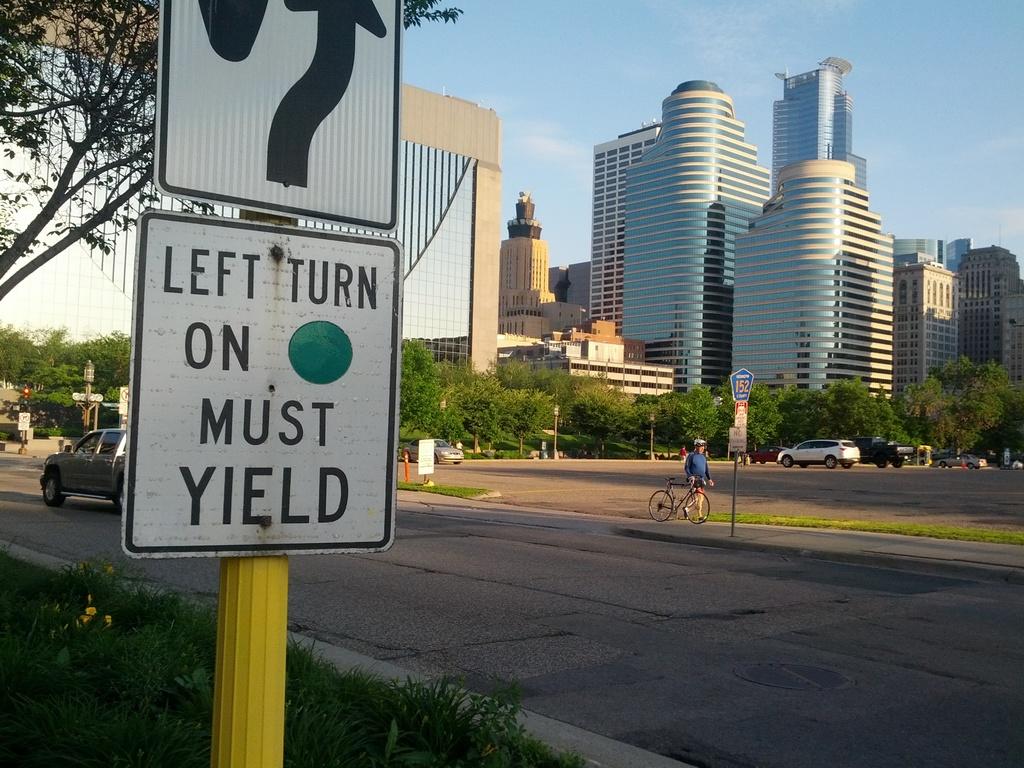What do you do on green?
Make the answer very short. Yield. 